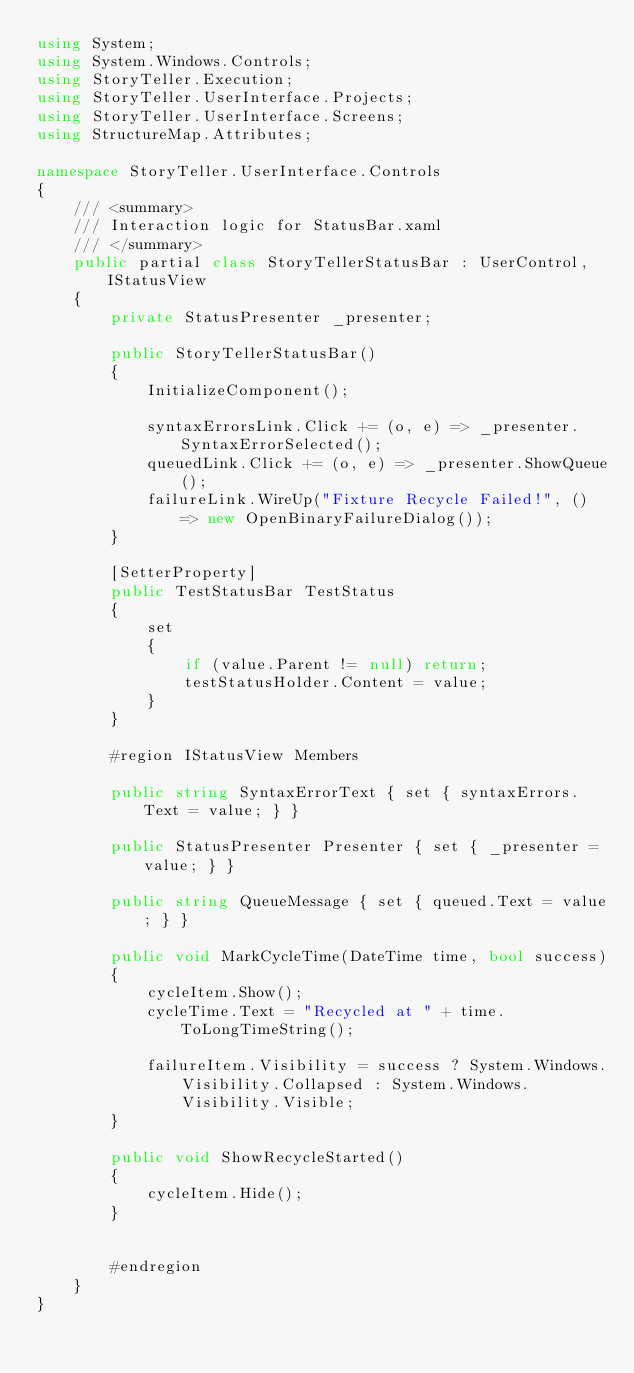<code> <loc_0><loc_0><loc_500><loc_500><_C#_>using System;
using System.Windows.Controls;
using StoryTeller.Execution;
using StoryTeller.UserInterface.Projects;
using StoryTeller.UserInterface.Screens;
using StructureMap.Attributes;

namespace StoryTeller.UserInterface.Controls
{
    /// <summary>
    /// Interaction logic for StatusBar.xaml
    /// </summary>
    public partial class StoryTellerStatusBar : UserControl, IStatusView
    {
        private StatusPresenter _presenter;

        public StoryTellerStatusBar()
        {
            InitializeComponent();

            syntaxErrorsLink.Click += (o, e) => _presenter.SyntaxErrorSelected();
            queuedLink.Click += (o, e) => _presenter.ShowQueue();
            failureLink.WireUp("Fixture Recycle Failed!", () => new OpenBinaryFailureDialog());
        }

        [SetterProperty]
        public TestStatusBar TestStatus
        {
            set
            {
                if (value.Parent != null) return;
                testStatusHolder.Content = value;
            }
        }

        #region IStatusView Members

        public string SyntaxErrorText { set { syntaxErrors.Text = value; } }

        public StatusPresenter Presenter { set { _presenter = value; } }

        public string QueueMessage { set { queued.Text = value; } }

        public void MarkCycleTime(DateTime time, bool success)
        {
            cycleItem.Show();
            cycleTime.Text = "Recycled at " + time.ToLongTimeString();

            failureItem.Visibility = success ? System.Windows.Visibility.Collapsed : System.Windows.Visibility.Visible;
        }

        public void ShowRecycleStarted()
        {
            cycleItem.Hide();
        }


        #endregion
    }
}</code> 